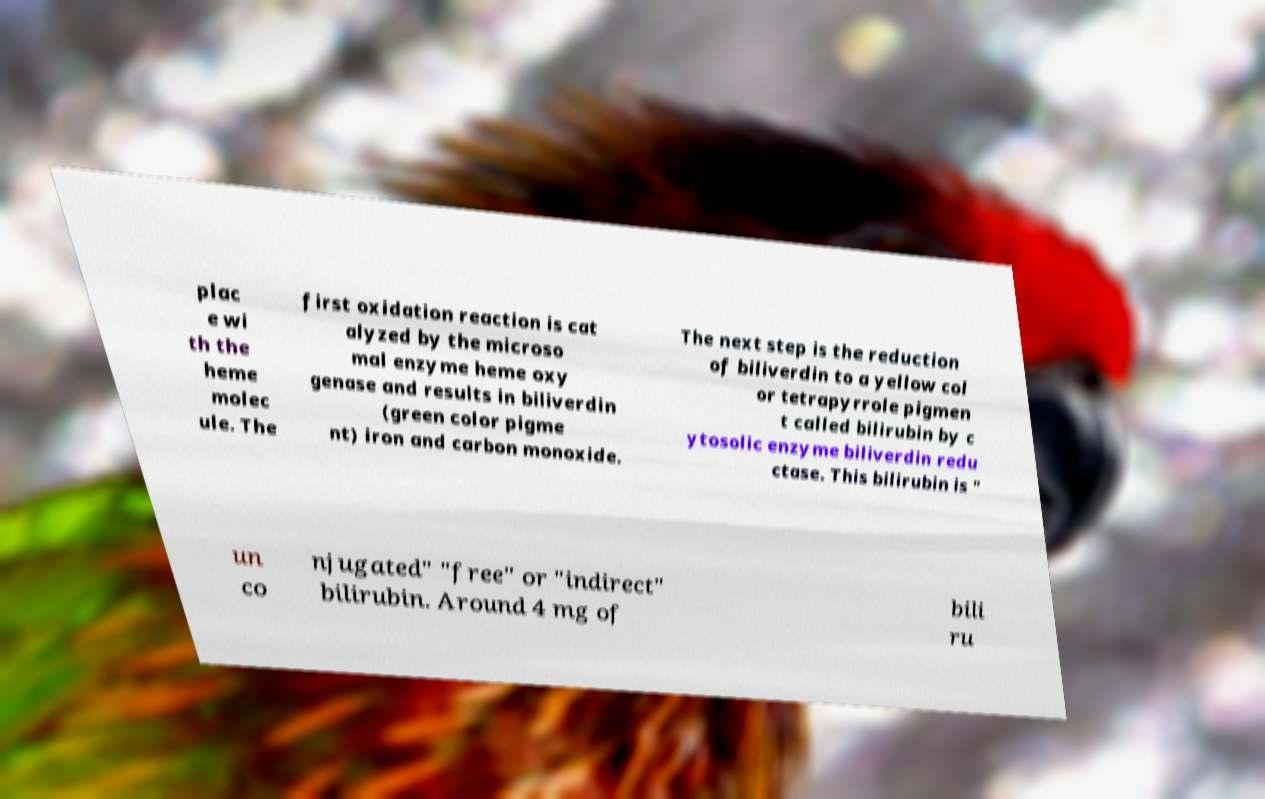For documentation purposes, I need the text within this image transcribed. Could you provide that? plac e wi th the heme molec ule. The first oxidation reaction is cat alyzed by the microso mal enzyme heme oxy genase and results in biliverdin (green color pigme nt) iron and carbon monoxide. The next step is the reduction of biliverdin to a yellow col or tetrapyrrole pigmen t called bilirubin by c ytosolic enzyme biliverdin redu ctase. This bilirubin is " un co njugated" "free" or "indirect" bilirubin. Around 4 mg of bili ru 